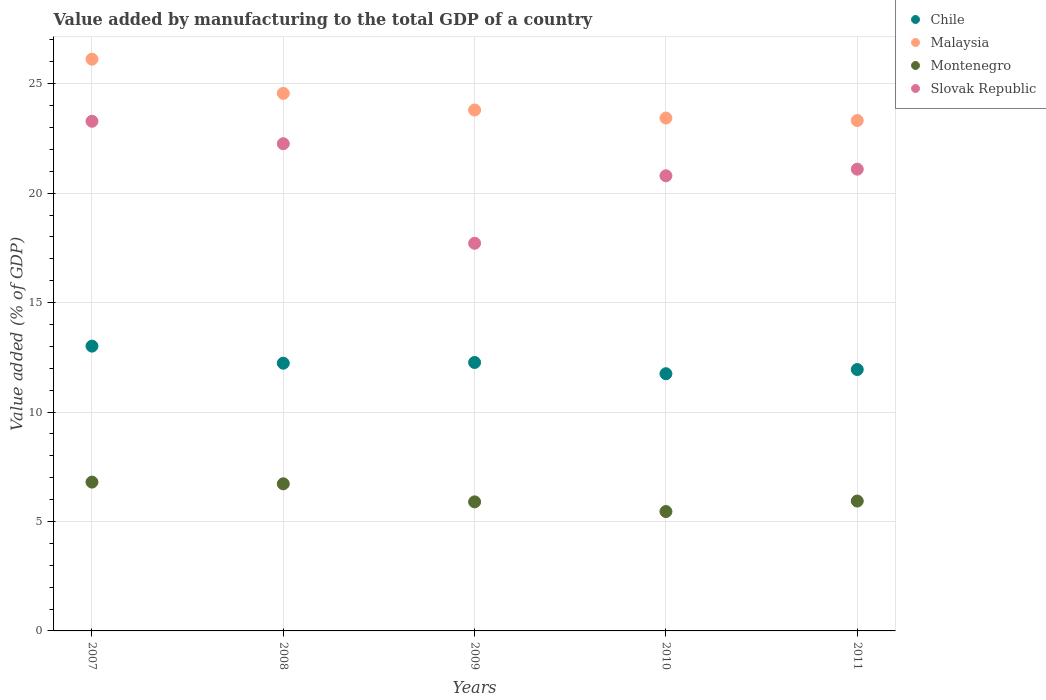What is the value added by manufacturing to the total GDP in Malaysia in 2008?
Your answer should be compact. 24.56. Across all years, what is the maximum value added by manufacturing to the total GDP in Montenegro?
Give a very brief answer. 6.8. Across all years, what is the minimum value added by manufacturing to the total GDP in Montenegro?
Make the answer very short. 5.45. In which year was the value added by manufacturing to the total GDP in Malaysia maximum?
Make the answer very short. 2007. What is the total value added by manufacturing to the total GDP in Malaysia in the graph?
Give a very brief answer. 121.24. What is the difference between the value added by manufacturing to the total GDP in Chile in 2007 and that in 2010?
Keep it short and to the point. 1.26. What is the difference between the value added by manufacturing to the total GDP in Slovak Republic in 2009 and the value added by manufacturing to the total GDP in Chile in 2007?
Offer a very short reply. 4.7. What is the average value added by manufacturing to the total GDP in Slovak Republic per year?
Your answer should be very brief. 21.03. In the year 2010, what is the difference between the value added by manufacturing to the total GDP in Slovak Republic and value added by manufacturing to the total GDP in Montenegro?
Offer a very short reply. 15.34. In how many years, is the value added by manufacturing to the total GDP in Montenegro greater than 2 %?
Your answer should be compact. 5. What is the ratio of the value added by manufacturing to the total GDP in Chile in 2007 to that in 2008?
Keep it short and to the point. 1.06. Is the value added by manufacturing to the total GDP in Slovak Republic in 2008 less than that in 2011?
Your answer should be very brief. No. Is the difference between the value added by manufacturing to the total GDP in Slovak Republic in 2009 and 2011 greater than the difference between the value added by manufacturing to the total GDP in Montenegro in 2009 and 2011?
Give a very brief answer. No. What is the difference between the highest and the second highest value added by manufacturing to the total GDP in Malaysia?
Offer a very short reply. 1.56. What is the difference between the highest and the lowest value added by manufacturing to the total GDP in Slovak Republic?
Offer a terse response. 5.57. Does the value added by manufacturing to the total GDP in Slovak Republic monotonically increase over the years?
Provide a short and direct response. No. Is the value added by manufacturing to the total GDP in Chile strictly greater than the value added by manufacturing to the total GDP in Malaysia over the years?
Your answer should be compact. No. Is the value added by manufacturing to the total GDP in Chile strictly less than the value added by manufacturing to the total GDP in Montenegro over the years?
Make the answer very short. No. How many years are there in the graph?
Keep it short and to the point. 5. Are the values on the major ticks of Y-axis written in scientific E-notation?
Offer a very short reply. No. Does the graph contain any zero values?
Give a very brief answer. No. Does the graph contain grids?
Provide a succinct answer. Yes. How many legend labels are there?
Give a very brief answer. 4. What is the title of the graph?
Your answer should be compact. Value added by manufacturing to the total GDP of a country. What is the label or title of the Y-axis?
Provide a succinct answer. Value added (% of GDP). What is the Value added (% of GDP) in Chile in 2007?
Provide a short and direct response. 13.01. What is the Value added (% of GDP) of Malaysia in 2007?
Offer a very short reply. 26.12. What is the Value added (% of GDP) in Montenegro in 2007?
Your answer should be compact. 6.8. What is the Value added (% of GDP) in Slovak Republic in 2007?
Your response must be concise. 23.29. What is the Value added (% of GDP) of Chile in 2008?
Your answer should be compact. 12.23. What is the Value added (% of GDP) in Malaysia in 2008?
Keep it short and to the point. 24.56. What is the Value added (% of GDP) of Montenegro in 2008?
Provide a short and direct response. 6.72. What is the Value added (% of GDP) in Slovak Republic in 2008?
Offer a terse response. 22.26. What is the Value added (% of GDP) in Chile in 2009?
Your answer should be compact. 12.27. What is the Value added (% of GDP) of Malaysia in 2009?
Make the answer very short. 23.8. What is the Value added (% of GDP) in Montenegro in 2009?
Make the answer very short. 5.9. What is the Value added (% of GDP) in Slovak Republic in 2009?
Keep it short and to the point. 17.71. What is the Value added (% of GDP) of Chile in 2010?
Offer a very short reply. 11.75. What is the Value added (% of GDP) of Malaysia in 2010?
Ensure brevity in your answer.  23.43. What is the Value added (% of GDP) in Montenegro in 2010?
Make the answer very short. 5.45. What is the Value added (% of GDP) in Slovak Republic in 2010?
Your response must be concise. 20.8. What is the Value added (% of GDP) of Chile in 2011?
Provide a short and direct response. 11.94. What is the Value added (% of GDP) of Malaysia in 2011?
Provide a succinct answer. 23.32. What is the Value added (% of GDP) of Montenegro in 2011?
Offer a terse response. 5.93. What is the Value added (% of GDP) in Slovak Republic in 2011?
Your response must be concise. 21.1. Across all years, what is the maximum Value added (% of GDP) in Chile?
Provide a short and direct response. 13.01. Across all years, what is the maximum Value added (% of GDP) of Malaysia?
Ensure brevity in your answer.  26.12. Across all years, what is the maximum Value added (% of GDP) in Montenegro?
Provide a short and direct response. 6.8. Across all years, what is the maximum Value added (% of GDP) in Slovak Republic?
Your answer should be very brief. 23.29. Across all years, what is the minimum Value added (% of GDP) in Chile?
Offer a terse response. 11.75. Across all years, what is the minimum Value added (% of GDP) in Malaysia?
Keep it short and to the point. 23.32. Across all years, what is the minimum Value added (% of GDP) in Montenegro?
Give a very brief answer. 5.45. Across all years, what is the minimum Value added (% of GDP) of Slovak Republic?
Make the answer very short. 17.71. What is the total Value added (% of GDP) of Chile in the graph?
Your answer should be very brief. 61.2. What is the total Value added (% of GDP) of Malaysia in the graph?
Keep it short and to the point. 121.24. What is the total Value added (% of GDP) in Montenegro in the graph?
Ensure brevity in your answer.  30.81. What is the total Value added (% of GDP) of Slovak Republic in the graph?
Provide a succinct answer. 105.15. What is the difference between the Value added (% of GDP) of Chile in 2007 and that in 2008?
Give a very brief answer. 0.78. What is the difference between the Value added (% of GDP) in Malaysia in 2007 and that in 2008?
Your response must be concise. 1.56. What is the difference between the Value added (% of GDP) in Montenegro in 2007 and that in 2008?
Offer a very short reply. 0.08. What is the difference between the Value added (% of GDP) in Slovak Republic in 2007 and that in 2008?
Give a very brief answer. 1.03. What is the difference between the Value added (% of GDP) of Chile in 2007 and that in 2009?
Offer a terse response. 0.75. What is the difference between the Value added (% of GDP) of Malaysia in 2007 and that in 2009?
Offer a very short reply. 2.32. What is the difference between the Value added (% of GDP) of Montenegro in 2007 and that in 2009?
Provide a succinct answer. 0.9. What is the difference between the Value added (% of GDP) of Slovak Republic in 2007 and that in 2009?
Provide a succinct answer. 5.57. What is the difference between the Value added (% of GDP) of Chile in 2007 and that in 2010?
Provide a succinct answer. 1.26. What is the difference between the Value added (% of GDP) in Malaysia in 2007 and that in 2010?
Offer a very short reply. 2.69. What is the difference between the Value added (% of GDP) of Montenegro in 2007 and that in 2010?
Your answer should be compact. 1.35. What is the difference between the Value added (% of GDP) of Slovak Republic in 2007 and that in 2010?
Your answer should be compact. 2.49. What is the difference between the Value added (% of GDP) in Chile in 2007 and that in 2011?
Offer a very short reply. 1.07. What is the difference between the Value added (% of GDP) in Malaysia in 2007 and that in 2011?
Keep it short and to the point. 2.8. What is the difference between the Value added (% of GDP) of Montenegro in 2007 and that in 2011?
Your answer should be very brief. 0.87. What is the difference between the Value added (% of GDP) in Slovak Republic in 2007 and that in 2011?
Keep it short and to the point. 2.19. What is the difference between the Value added (% of GDP) of Chile in 2008 and that in 2009?
Offer a very short reply. -0.03. What is the difference between the Value added (% of GDP) in Malaysia in 2008 and that in 2009?
Make the answer very short. 0.76. What is the difference between the Value added (% of GDP) in Montenegro in 2008 and that in 2009?
Give a very brief answer. 0.83. What is the difference between the Value added (% of GDP) of Slovak Republic in 2008 and that in 2009?
Your answer should be very brief. 4.55. What is the difference between the Value added (% of GDP) of Chile in 2008 and that in 2010?
Offer a very short reply. 0.48. What is the difference between the Value added (% of GDP) of Malaysia in 2008 and that in 2010?
Give a very brief answer. 1.13. What is the difference between the Value added (% of GDP) in Montenegro in 2008 and that in 2010?
Offer a terse response. 1.27. What is the difference between the Value added (% of GDP) of Slovak Republic in 2008 and that in 2010?
Provide a short and direct response. 1.47. What is the difference between the Value added (% of GDP) of Chile in 2008 and that in 2011?
Give a very brief answer. 0.29. What is the difference between the Value added (% of GDP) in Malaysia in 2008 and that in 2011?
Make the answer very short. 1.24. What is the difference between the Value added (% of GDP) of Montenegro in 2008 and that in 2011?
Provide a succinct answer. 0.79. What is the difference between the Value added (% of GDP) of Slovak Republic in 2008 and that in 2011?
Make the answer very short. 1.16. What is the difference between the Value added (% of GDP) in Chile in 2009 and that in 2010?
Ensure brevity in your answer.  0.51. What is the difference between the Value added (% of GDP) in Malaysia in 2009 and that in 2010?
Provide a succinct answer. 0.37. What is the difference between the Value added (% of GDP) of Montenegro in 2009 and that in 2010?
Your answer should be very brief. 0.44. What is the difference between the Value added (% of GDP) in Slovak Republic in 2009 and that in 2010?
Make the answer very short. -3.08. What is the difference between the Value added (% of GDP) in Chile in 2009 and that in 2011?
Make the answer very short. 0.32. What is the difference between the Value added (% of GDP) in Malaysia in 2009 and that in 2011?
Keep it short and to the point. 0.48. What is the difference between the Value added (% of GDP) of Montenegro in 2009 and that in 2011?
Make the answer very short. -0.04. What is the difference between the Value added (% of GDP) of Slovak Republic in 2009 and that in 2011?
Keep it short and to the point. -3.39. What is the difference between the Value added (% of GDP) of Chile in 2010 and that in 2011?
Offer a terse response. -0.19. What is the difference between the Value added (% of GDP) in Malaysia in 2010 and that in 2011?
Make the answer very short. 0.11. What is the difference between the Value added (% of GDP) in Montenegro in 2010 and that in 2011?
Your answer should be compact. -0.48. What is the difference between the Value added (% of GDP) in Slovak Republic in 2010 and that in 2011?
Your response must be concise. -0.3. What is the difference between the Value added (% of GDP) in Chile in 2007 and the Value added (% of GDP) in Malaysia in 2008?
Ensure brevity in your answer.  -11.55. What is the difference between the Value added (% of GDP) in Chile in 2007 and the Value added (% of GDP) in Montenegro in 2008?
Your response must be concise. 6.29. What is the difference between the Value added (% of GDP) of Chile in 2007 and the Value added (% of GDP) of Slovak Republic in 2008?
Ensure brevity in your answer.  -9.25. What is the difference between the Value added (% of GDP) of Malaysia in 2007 and the Value added (% of GDP) of Montenegro in 2008?
Your answer should be very brief. 19.4. What is the difference between the Value added (% of GDP) of Malaysia in 2007 and the Value added (% of GDP) of Slovak Republic in 2008?
Offer a terse response. 3.86. What is the difference between the Value added (% of GDP) of Montenegro in 2007 and the Value added (% of GDP) of Slovak Republic in 2008?
Ensure brevity in your answer.  -15.46. What is the difference between the Value added (% of GDP) in Chile in 2007 and the Value added (% of GDP) in Malaysia in 2009?
Your answer should be very brief. -10.79. What is the difference between the Value added (% of GDP) of Chile in 2007 and the Value added (% of GDP) of Montenegro in 2009?
Your answer should be compact. 7.12. What is the difference between the Value added (% of GDP) in Chile in 2007 and the Value added (% of GDP) in Slovak Republic in 2009?
Offer a very short reply. -4.7. What is the difference between the Value added (% of GDP) in Malaysia in 2007 and the Value added (% of GDP) in Montenegro in 2009?
Provide a short and direct response. 20.23. What is the difference between the Value added (% of GDP) in Malaysia in 2007 and the Value added (% of GDP) in Slovak Republic in 2009?
Keep it short and to the point. 8.41. What is the difference between the Value added (% of GDP) of Montenegro in 2007 and the Value added (% of GDP) of Slovak Republic in 2009?
Your answer should be very brief. -10.91. What is the difference between the Value added (% of GDP) in Chile in 2007 and the Value added (% of GDP) in Malaysia in 2010?
Give a very brief answer. -10.42. What is the difference between the Value added (% of GDP) of Chile in 2007 and the Value added (% of GDP) of Montenegro in 2010?
Provide a succinct answer. 7.56. What is the difference between the Value added (% of GDP) in Chile in 2007 and the Value added (% of GDP) in Slovak Republic in 2010?
Offer a very short reply. -7.78. What is the difference between the Value added (% of GDP) of Malaysia in 2007 and the Value added (% of GDP) of Montenegro in 2010?
Provide a short and direct response. 20.67. What is the difference between the Value added (% of GDP) of Malaysia in 2007 and the Value added (% of GDP) of Slovak Republic in 2010?
Offer a terse response. 5.33. What is the difference between the Value added (% of GDP) of Montenegro in 2007 and the Value added (% of GDP) of Slovak Republic in 2010?
Offer a very short reply. -14. What is the difference between the Value added (% of GDP) of Chile in 2007 and the Value added (% of GDP) of Malaysia in 2011?
Your response must be concise. -10.31. What is the difference between the Value added (% of GDP) of Chile in 2007 and the Value added (% of GDP) of Montenegro in 2011?
Ensure brevity in your answer.  7.08. What is the difference between the Value added (% of GDP) of Chile in 2007 and the Value added (% of GDP) of Slovak Republic in 2011?
Keep it short and to the point. -8.09. What is the difference between the Value added (% of GDP) of Malaysia in 2007 and the Value added (% of GDP) of Montenegro in 2011?
Offer a terse response. 20.19. What is the difference between the Value added (% of GDP) in Malaysia in 2007 and the Value added (% of GDP) in Slovak Republic in 2011?
Your response must be concise. 5.02. What is the difference between the Value added (% of GDP) of Montenegro in 2007 and the Value added (% of GDP) of Slovak Republic in 2011?
Your answer should be compact. -14.3. What is the difference between the Value added (% of GDP) in Chile in 2008 and the Value added (% of GDP) in Malaysia in 2009?
Provide a succinct answer. -11.57. What is the difference between the Value added (% of GDP) in Chile in 2008 and the Value added (% of GDP) in Montenegro in 2009?
Your answer should be compact. 6.34. What is the difference between the Value added (% of GDP) in Chile in 2008 and the Value added (% of GDP) in Slovak Republic in 2009?
Provide a short and direct response. -5.48. What is the difference between the Value added (% of GDP) of Malaysia in 2008 and the Value added (% of GDP) of Montenegro in 2009?
Provide a short and direct response. 18.66. What is the difference between the Value added (% of GDP) of Malaysia in 2008 and the Value added (% of GDP) of Slovak Republic in 2009?
Keep it short and to the point. 6.85. What is the difference between the Value added (% of GDP) of Montenegro in 2008 and the Value added (% of GDP) of Slovak Republic in 2009?
Ensure brevity in your answer.  -10.99. What is the difference between the Value added (% of GDP) of Chile in 2008 and the Value added (% of GDP) of Malaysia in 2010?
Give a very brief answer. -11.2. What is the difference between the Value added (% of GDP) in Chile in 2008 and the Value added (% of GDP) in Montenegro in 2010?
Make the answer very short. 6.78. What is the difference between the Value added (% of GDP) in Chile in 2008 and the Value added (% of GDP) in Slovak Republic in 2010?
Your answer should be compact. -8.56. What is the difference between the Value added (% of GDP) in Malaysia in 2008 and the Value added (% of GDP) in Montenegro in 2010?
Give a very brief answer. 19.11. What is the difference between the Value added (% of GDP) in Malaysia in 2008 and the Value added (% of GDP) in Slovak Republic in 2010?
Your response must be concise. 3.77. What is the difference between the Value added (% of GDP) of Montenegro in 2008 and the Value added (% of GDP) of Slovak Republic in 2010?
Your response must be concise. -14.07. What is the difference between the Value added (% of GDP) in Chile in 2008 and the Value added (% of GDP) in Malaysia in 2011?
Provide a short and direct response. -11.09. What is the difference between the Value added (% of GDP) of Chile in 2008 and the Value added (% of GDP) of Montenegro in 2011?
Your answer should be compact. 6.3. What is the difference between the Value added (% of GDP) of Chile in 2008 and the Value added (% of GDP) of Slovak Republic in 2011?
Ensure brevity in your answer.  -8.87. What is the difference between the Value added (% of GDP) in Malaysia in 2008 and the Value added (% of GDP) in Montenegro in 2011?
Your answer should be very brief. 18.63. What is the difference between the Value added (% of GDP) in Malaysia in 2008 and the Value added (% of GDP) in Slovak Republic in 2011?
Your answer should be very brief. 3.46. What is the difference between the Value added (% of GDP) in Montenegro in 2008 and the Value added (% of GDP) in Slovak Republic in 2011?
Offer a very short reply. -14.38. What is the difference between the Value added (% of GDP) in Chile in 2009 and the Value added (% of GDP) in Malaysia in 2010?
Your answer should be compact. -11.17. What is the difference between the Value added (% of GDP) in Chile in 2009 and the Value added (% of GDP) in Montenegro in 2010?
Give a very brief answer. 6.81. What is the difference between the Value added (% of GDP) in Chile in 2009 and the Value added (% of GDP) in Slovak Republic in 2010?
Keep it short and to the point. -8.53. What is the difference between the Value added (% of GDP) in Malaysia in 2009 and the Value added (% of GDP) in Montenegro in 2010?
Your response must be concise. 18.35. What is the difference between the Value added (% of GDP) of Malaysia in 2009 and the Value added (% of GDP) of Slovak Republic in 2010?
Your response must be concise. 3. What is the difference between the Value added (% of GDP) of Montenegro in 2009 and the Value added (% of GDP) of Slovak Republic in 2010?
Offer a terse response. -14.9. What is the difference between the Value added (% of GDP) in Chile in 2009 and the Value added (% of GDP) in Malaysia in 2011?
Provide a short and direct response. -11.05. What is the difference between the Value added (% of GDP) of Chile in 2009 and the Value added (% of GDP) of Montenegro in 2011?
Provide a succinct answer. 6.33. What is the difference between the Value added (% of GDP) in Chile in 2009 and the Value added (% of GDP) in Slovak Republic in 2011?
Ensure brevity in your answer.  -8.83. What is the difference between the Value added (% of GDP) in Malaysia in 2009 and the Value added (% of GDP) in Montenegro in 2011?
Provide a short and direct response. 17.87. What is the difference between the Value added (% of GDP) in Malaysia in 2009 and the Value added (% of GDP) in Slovak Republic in 2011?
Provide a succinct answer. 2.7. What is the difference between the Value added (% of GDP) of Montenegro in 2009 and the Value added (% of GDP) of Slovak Republic in 2011?
Offer a terse response. -15.2. What is the difference between the Value added (% of GDP) of Chile in 2010 and the Value added (% of GDP) of Malaysia in 2011?
Keep it short and to the point. -11.57. What is the difference between the Value added (% of GDP) of Chile in 2010 and the Value added (% of GDP) of Montenegro in 2011?
Your response must be concise. 5.82. What is the difference between the Value added (% of GDP) in Chile in 2010 and the Value added (% of GDP) in Slovak Republic in 2011?
Give a very brief answer. -9.35. What is the difference between the Value added (% of GDP) of Malaysia in 2010 and the Value added (% of GDP) of Montenegro in 2011?
Provide a succinct answer. 17.5. What is the difference between the Value added (% of GDP) in Malaysia in 2010 and the Value added (% of GDP) in Slovak Republic in 2011?
Offer a very short reply. 2.34. What is the difference between the Value added (% of GDP) in Montenegro in 2010 and the Value added (% of GDP) in Slovak Republic in 2011?
Your answer should be compact. -15.64. What is the average Value added (% of GDP) in Chile per year?
Your answer should be compact. 12.24. What is the average Value added (% of GDP) of Malaysia per year?
Your response must be concise. 24.25. What is the average Value added (% of GDP) in Montenegro per year?
Your answer should be very brief. 6.16. What is the average Value added (% of GDP) of Slovak Republic per year?
Give a very brief answer. 21.03. In the year 2007, what is the difference between the Value added (% of GDP) of Chile and Value added (% of GDP) of Malaysia?
Your answer should be very brief. -13.11. In the year 2007, what is the difference between the Value added (% of GDP) of Chile and Value added (% of GDP) of Montenegro?
Provide a short and direct response. 6.21. In the year 2007, what is the difference between the Value added (% of GDP) in Chile and Value added (% of GDP) in Slovak Republic?
Provide a short and direct response. -10.27. In the year 2007, what is the difference between the Value added (% of GDP) in Malaysia and Value added (% of GDP) in Montenegro?
Your answer should be compact. 19.32. In the year 2007, what is the difference between the Value added (% of GDP) in Malaysia and Value added (% of GDP) in Slovak Republic?
Your answer should be compact. 2.84. In the year 2007, what is the difference between the Value added (% of GDP) in Montenegro and Value added (% of GDP) in Slovak Republic?
Make the answer very short. -16.49. In the year 2008, what is the difference between the Value added (% of GDP) of Chile and Value added (% of GDP) of Malaysia?
Make the answer very short. -12.33. In the year 2008, what is the difference between the Value added (% of GDP) of Chile and Value added (% of GDP) of Montenegro?
Provide a short and direct response. 5.51. In the year 2008, what is the difference between the Value added (% of GDP) of Chile and Value added (% of GDP) of Slovak Republic?
Your response must be concise. -10.03. In the year 2008, what is the difference between the Value added (% of GDP) of Malaysia and Value added (% of GDP) of Montenegro?
Keep it short and to the point. 17.84. In the year 2008, what is the difference between the Value added (% of GDP) in Malaysia and Value added (% of GDP) in Slovak Republic?
Offer a terse response. 2.3. In the year 2008, what is the difference between the Value added (% of GDP) of Montenegro and Value added (% of GDP) of Slovak Republic?
Your answer should be compact. -15.54. In the year 2009, what is the difference between the Value added (% of GDP) in Chile and Value added (% of GDP) in Malaysia?
Give a very brief answer. -11.53. In the year 2009, what is the difference between the Value added (% of GDP) in Chile and Value added (% of GDP) in Montenegro?
Provide a short and direct response. 6.37. In the year 2009, what is the difference between the Value added (% of GDP) of Chile and Value added (% of GDP) of Slovak Republic?
Offer a terse response. -5.45. In the year 2009, what is the difference between the Value added (% of GDP) in Malaysia and Value added (% of GDP) in Montenegro?
Provide a succinct answer. 17.9. In the year 2009, what is the difference between the Value added (% of GDP) of Malaysia and Value added (% of GDP) of Slovak Republic?
Keep it short and to the point. 6.09. In the year 2009, what is the difference between the Value added (% of GDP) of Montenegro and Value added (% of GDP) of Slovak Republic?
Your answer should be compact. -11.82. In the year 2010, what is the difference between the Value added (% of GDP) of Chile and Value added (% of GDP) of Malaysia?
Provide a succinct answer. -11.68. In the year 2010, what is the difference between the Value added (% of GDP) of Chile and Value added (% of GDP) of Montenegro?
Make the answer very short. 6.3. In the year 2010, what is the difference between the Value added (% of GDP) in Chile and Value added (% of GDP) in Slovak Republic?
Offer a terse response. -9.04. In the year 2010, what is the difference between the Value added (% of GDP) of Malaysia and Value added (% of GDP) of Montenegro?
Provide a succinct answer. 17.98. In the year 2010, what is the difference between the Value added (% of GDP) of Malaysia and Value added (% of GDP) of Slovak Republic?
Make the answer very short. 2.64. In the year 2010, what is the difference between the Value added (% of GDP) of Montenegro and Value added (% of GDP) of Slovak Republic?
Your answer should be very brief. -15.34. In the year 2011, what is the difference between the Value added (% of GDP) of Chile and Value added (% of GDP) of Malaysia?
Provide a short and direct response. -11.38. In the year 2011, what is the difference between the Value added (% of GDP) of Chile and Value added (% of GDP) of Montenegro?
Ensure brevity in your answer.  6.01. In the year 2011, what is the difference between the Value added (% of GDP) in Chile and Value added (% of GDP) in Slovak Republic?
Your answer should be very brief. -9.15. In the year 2011, what is the difference between the Value added (% of GDP) of Malaysia and Value added (% of GDP) of Montenegro?
Your answer should be compact. 17.39. In the year 2011, what is the difference between the Value added (% of GDP) of Malaysia and Value added (% of GDP) of Slovak Republic?
Offer a terse response. 2.22. In the year 2011, what is the difference between the Value added (% of GDP) of Montenegro and Value added (% of GDP) of Slovak Republic?
Provide a short and direct response. -15.16. What is the ratio of the Value added (% of GDP) of Chile in 2007 to that in 2008?
Offer a terse response. 1.06. What is the ratio of the Value added (% of GDP) in Malaysia in 2007 to that in 2008?
Offer a terse response. 1.06. What is the ratio of the Value added (% of GDP) in Montenegro in 2007 to that in 2008?
Keep it short and to the point. 1.01. What is the ratio of the Value added (% of GDP) of Slovak Republic in 2007 to that in 2008?
Ensure brevity in your answer.  1.05. What is the ratio of the Value added (% of GDP) of Chile in 2007 to that in 2009?
Your response must be concise. 1.06. What is the ratio of the Value added (% of GDP) in Malaysia in 2007 to that in 2009?
Give a very brief answer. 1.1. What is the ratio of the Value added (% of GDP) of Montenegro in 2007 to that in 2009?
Offer a very short reply. 1.15. What is the ratio of the Value added (% of GDP) of Slovak Republic in 2007 to that in 2009?
Offer a terse response. 1.31. What is the ratio of the Value added (% of GDP) of Chile in 2007 to that in 2010?
Provide a succinct answer. 1.11. What is the ratio of the Value added (% of GDP) in Malaysia in 2007 to that in 2010?
Offer a very short reply. 1.11. What is the ratio of the Value added (% of GDP) of Montenegro in 2007 to that in 2010?
Your answer should be compact. 1.25. What is the ratio of the Value added (% of GDP) in Slovak Republic in 2007 to that in 2010?
Keep it short and to the point. 1.12. What is the ratio of the Value added (% of GDP) in Chile in 2007 to that in 2011?
Offer a very short reply. 1.09. What is the ratio of the Value added (% of GDP) of Malaysia in 2007 to that in 2011?
Your response must be concise. 1.12. What is the ratio of the Value added (% of GDP) in Montenegro in 2007 to that in 2011?
Give a very brief answer. 1.15. What is the ratio of the Value added (% of GDP) of Slovak Republic in 2007 to that in 2011?
Your answer should be very brief. 1.1. What is the ratio of the Value added (% of GDP) in Malaysia in 2008 to that in 2009?
Offer a terse response. 1.03. What is the ratio of the Value added (% of GDP) of Montenegro in 2008 to that in 2009?
Keep it short and to the point. 1.14. What is the ratio of the Value added (% of GDP) of Slovak Republic in 2008 to that in 2009?
Ensure brevity in your answer.  1.26. What is the ratio of the Value added (% of GDP) of Chile in 2008 to that in 2010?
Provide a succinct answer. 1.04. What is the ratio of the Value added (% of GDP) in Malaysia in 2008 to that in 2010?
Give a very brief answer. 1.05. What is the ratio of the Value added (% of GDP) of Montenegro in 2008 to that in 2010?
Give a very brief answer. 1.23. What is the ratio of the Value added (% of GDP) in Slovak Republic in 2008 to that in 2010?
Keep it short and to the point. 1.07. What is the ratio of the Value added (% of GDP) in Chile in 2008 to that in 2011?
Give a very brief answer. 1.02. What is the ratio of the Value added (% of GDP) in Malaysia in 2008 to that in 2011?
Your answer should be compact. 1.05. What is the ratio of the Value added (% of GDP) of Montenegro in 2008 to that in 2011?
Provide a short and direct response. 1.13. What is the ratio of the Value added (% of GDP) in Slovak Republic in 2008 to that in 2011?
Provide a succinct answer. 1.06. What is the ratio of the Value added (% of GDP) in Chile in 2009 to that in 2010?
Give a very brief answer. 1.04. What is the ratio of the Value added (% of GDP) in Malaysia in 2009 to that in 2010?
Offer a very short reply. 1.02. What is the ratio of the Value added (% of GDP) of Montenegro in 2009 to that in 2010?
Keep it short and to the point. 1.08. What is the ratio of the Value added (% of GDP) of Slovak Republic in 2009 to that in 2010?
Ensure brevity in your answer.  0.85. What is the ratio of the Value added (% of GDP) in Malaysia in 2009 to that in 2011?
Your answer should be compact. 1.02. What is the ratio of the Value added (% of GDP) of Slovak Republic in 2009 to that in 2011?
Provide a short and direct response. 0.84. What is the ratio of the Value added (% of GDP) in Chile in 2010 to that in 2011?
Your response must be concise. 0.98. What is the ratio of the Value added (% of GDP) of Malaysia in 2010 to that in 2011?
Give a very brief answer. 1. What is the ratio of the Value added (% of GDP) of Montenegro in 2010 to that in 2011?
Your answer should be very brief. 0.92. What is the ratio of the Value added (% of GDP) in Slovak Republic in 2010 to that in 2011?
Your response must be concise. 0.99. What is the difference between the highest and the second highest Value added (% of GDP) of Chile?
Offer a very short reply. 0.75. What is the difference between the highest and the second highest Value added (% of GDP) in Malaysia?
Provide a short and direct response. 1.56. What is the difference between the highest and the second highest Value added (% of GDP) in Montenegro?
Give a very brief answer. 0.08. What is the difference between the highest and the second highest Value added (% of GDP) in Slovak Republic?
Give a very brief answer. 1.03. What is the difference between the highest and the lowest Value added (% of GDP) in Chile?
Give a very brief answer. 1.26. What is the difference between the highest and the lowest Value added (% of GDP) of Malaysia?
Make the answer very short. 2.8. What is the difference between the highest and the lowest Value added (% of GDP) in Montenegro?
Keep it short and to the point. 1.35. What is the difference between the highest and the lowest Value added (% of GDP) in Slovak Republic?
Make the answer very short. 5.57. 